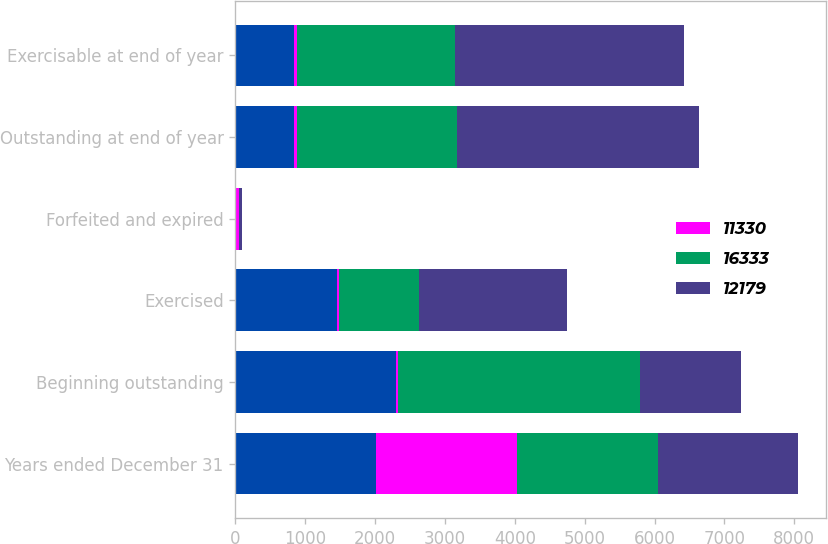Convert chart to OTSL. <chart><loc_0><loc_0><loc_500><loc_500><stacked_bar_chart><ecel><fcel>Years ended December 31<fcel>Beginning outstanding<fcel>Exercised<fcel>Forfeited and expired<fcel>Outstanding at end of year<fcel>Exercisable at end of year<nl><fcel>nan<fcel>2015<fcel>2300<fcel>1450<fcel>13<fcel>837<fcel>837<nl><fcel>11330<fcel>2015<fcel>32<fcel>27<fcel>39<fcel>40<fcel>40<nl><fcel>16333<fcel>2014<fcel>3462<fcel>1155<fcel>7<fcel>2300<fcel>2273<nl><fcel>12179<fcel>2013<fcel>1450<fcel>2116<fcel>33<fcel>3462<fcel>3270<nl></chart> 